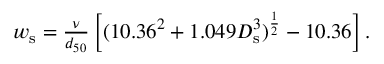<formula> <loc_0><loc_0><loc_500><loc_500>\begin{array} { r } { w _ { s } = \frac { \nu } { d _ { 5 0 } } \left [ ( 1 0 . 3 6 ^ { 2 } + 1 . 0 4 9 D _ { s } ^ { 3 } ) ^ { \frac { 1 } { 2 } } - 1 0 . 3 6 \right ] . } \end{array}</formula> 